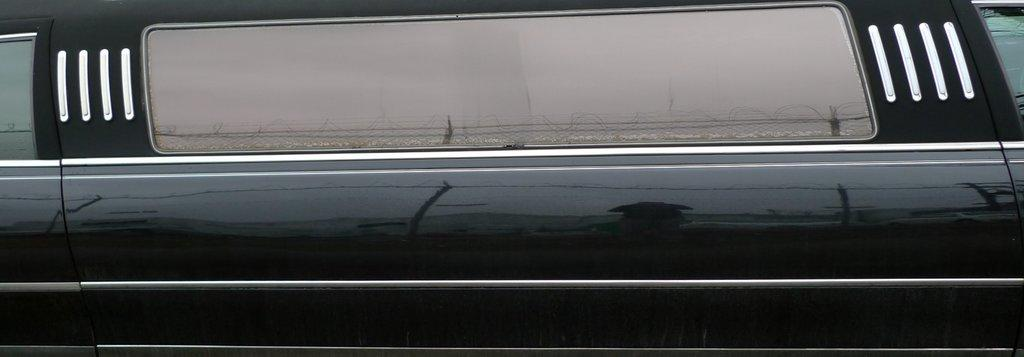What is the main subject in the picture? There is a vehicle in the picture. What can be observed on the surface of the vehicle? There is a reflection of a fence and the sky on the vehicle. What year is the vehicle from in the image? The provided facts do not mention the year of the vehicle, so it cannot be determined from the image. 